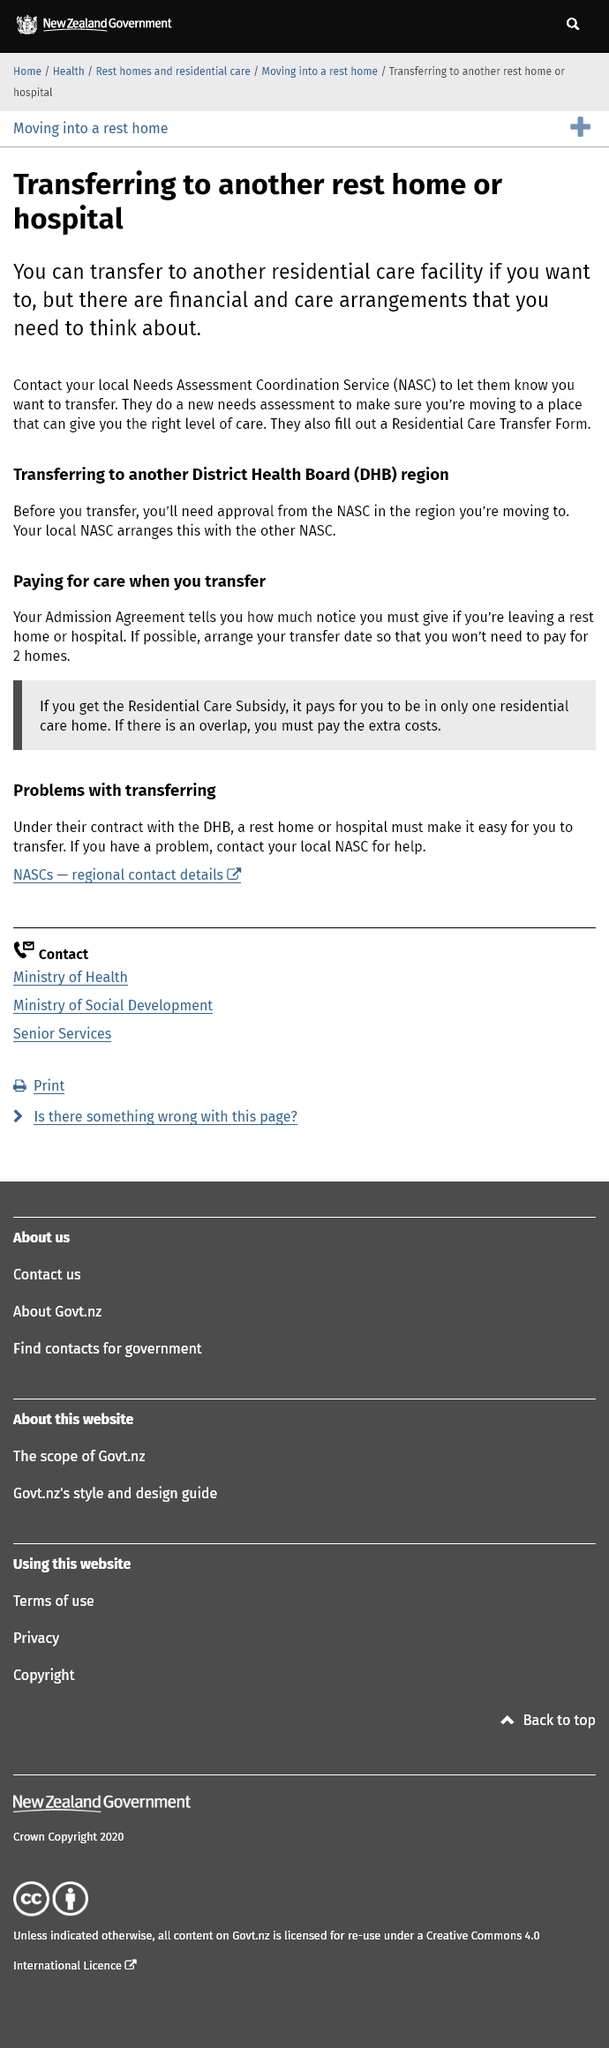Outline some significant characteristics in this image. According to the information provided, the minimum notice period that must be given if leaving a rest home or hospital is indicated in the Admission Agreement. When considering the transfer to another residential care facility, it is essential to consider two key factors: financial arrangements and care arrangements. It is imperative to carefully evaluate and plan for these factors in order to ensure a smooth transition for both the individual and the new facility. Yes, it is possible to transfer to another District Health Board region. 